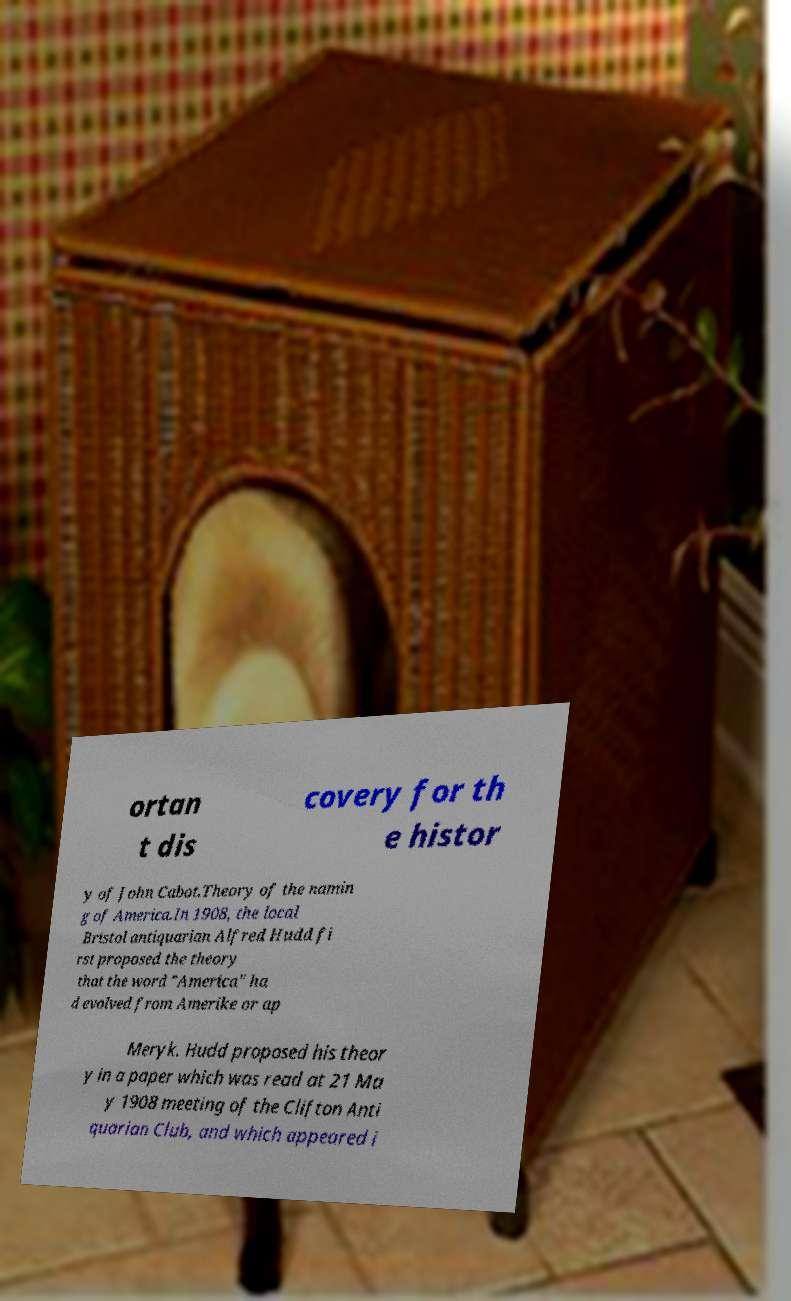Please identify and transcribe the text found in this image. ortan t dis covery for th e histor y of John Cabot.Theory of the namin g of America.In 1908, the local Bristol antiquarian Alfred Hudd fi rst proposed the theory that the word "America" ha d evolved from Amerike or ap Meryk. Hudd proposed his theor y in a paper which was read at 21 Ma y 1908 meeting of the Clifton Anti quarian Club, and which appeared i 